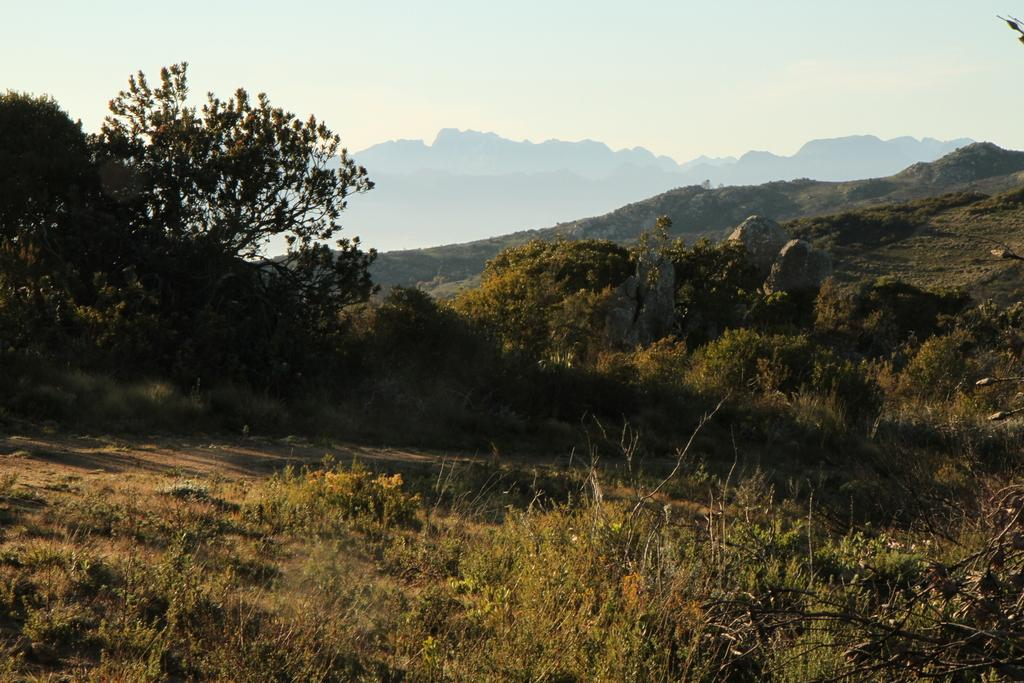What type of vegetation is present at the bottom of the image? There is grass on the ground at the bottom of the image. What other natural elements can be seen in the image? There are trees and rocks visible in the image. What is the landscape like in the background of the image? There are hills in the background of the image. What is visible at the top of the image? The sky is visible at the top of the image. How many roses are present in the image? There are no roses visible in the image. Can you describe the field where the cows are grazing in the image? There is no field or cows present in the image; it features grass, trees, rocks, hills, and a sky. 